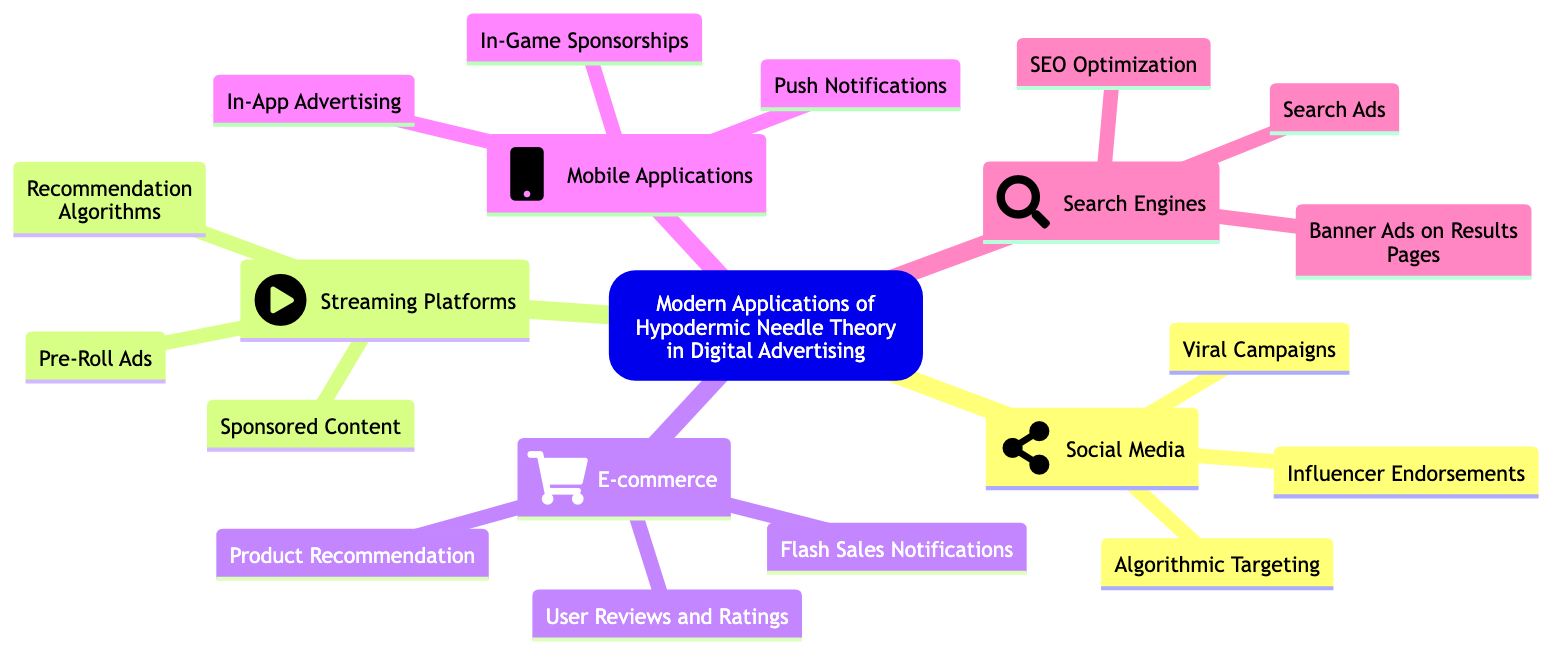What is the central idea of the mind map? The central idea is presented at the root of the mind map, clearly stating "Modern Applications of the Hypodermic Needle Theory in Digital Advertising." This is the primary focus of the entire map.
Answer: Modern Applications of the Hypodermic Needle Theory in Digital Advertising How many main branches are there in the mind map? By counting the primary nodes extending from the central idea, we identify that there are five main branches: Social Media, Streaming Platforms, E-commerce, Mobile Applications, and Search Engines.
Answer: 5 What key element is associated with Social Media? Reviewing the Social Media branch reveals three key elements: Algorithmic Targeting, Viral Campaigns, and Influencer Endorsements. We can choose any of those, but Algorithmic Targeting is a distinctive feature of this branch.
Answer: Algorithmic Targeting Which branch discusses direct messages in mobile applications? Looking at the branch about Mobile Applications, we can see that it explicitly addresses the role of ads within mobile apps, highlighting In-App Advertising and Push Notifications as key aspects. Thus, it is Mobile Applications.
Answer: Mobile Applications What is the focus of advertisement in E-commerce? The E-commerce branch lays out three specific advertising strategies like Product Recommendation and Flash Sales Notifications. The main focus here revolves around how these ads impact users’ decisions while shopping online.
Answer: Product Recommendation Which type of advertising appears before content on streaming platforms? The Streaming Platforms branch specifies Pre-Roll Ads, which are explicitly defined as short advertisements played before the main content begins, making it the obvious answer.
Answer: Pre-Roll Ads How does Search Ads influence user behavior? The Search Engines branch lists Search Ads, asserting that these are promoted search results that appear at the top of search listings, indicating a significant influence on user behavior through visibility.
Answer: Search Ads What is a characteristic feature of Influencer Endorsements in Social Media? Influencer Endorsements are identified under Social Media as powerful direct messages delivered via celebrities and influencer platforms, which can strongly sway public opinion and behavior.
Answer: Celebrities and influencers Which branch integrates brand messaging within shows? The Streaming Platforms branch discusses Sponsored Content, describing how brand messaging is incorporated into the plots or content of shows and streams, highlighting the seamless way ads can infiltrate entertainment.
Answer: Sponsored Content 